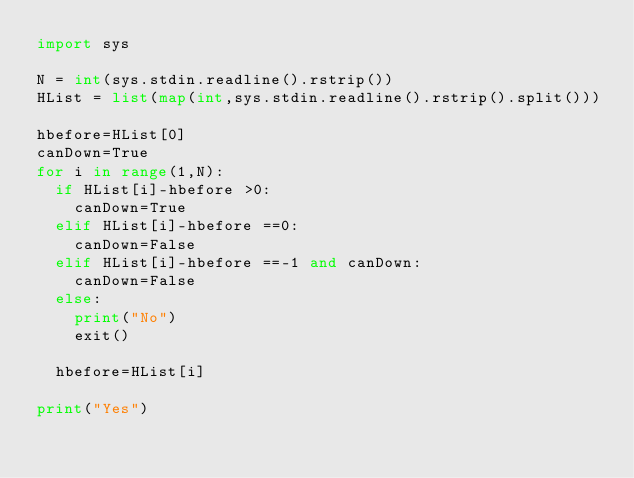<code> <loc_0><loc_0><loc_500><loc_500><_Python_>import sys

N = int(sys.stdin.readline().rstrip())
HList = list(map(int,sys.stdin.readline().rstrip().split()))

hbefore=HList[0]
canDown=True
for i in range(1,N):
  if HList[i]-hbefore >0:
    canDown=True
  elif HList[i]-hbefore ==0:
    canDown=False
  elif HList[i]-hbefore ==-1 and canDown:
    canDown=False    
  else:
    print("No")
    exit()
 
  hbefore=HList[i]
  
print("Yes")
  </code> 